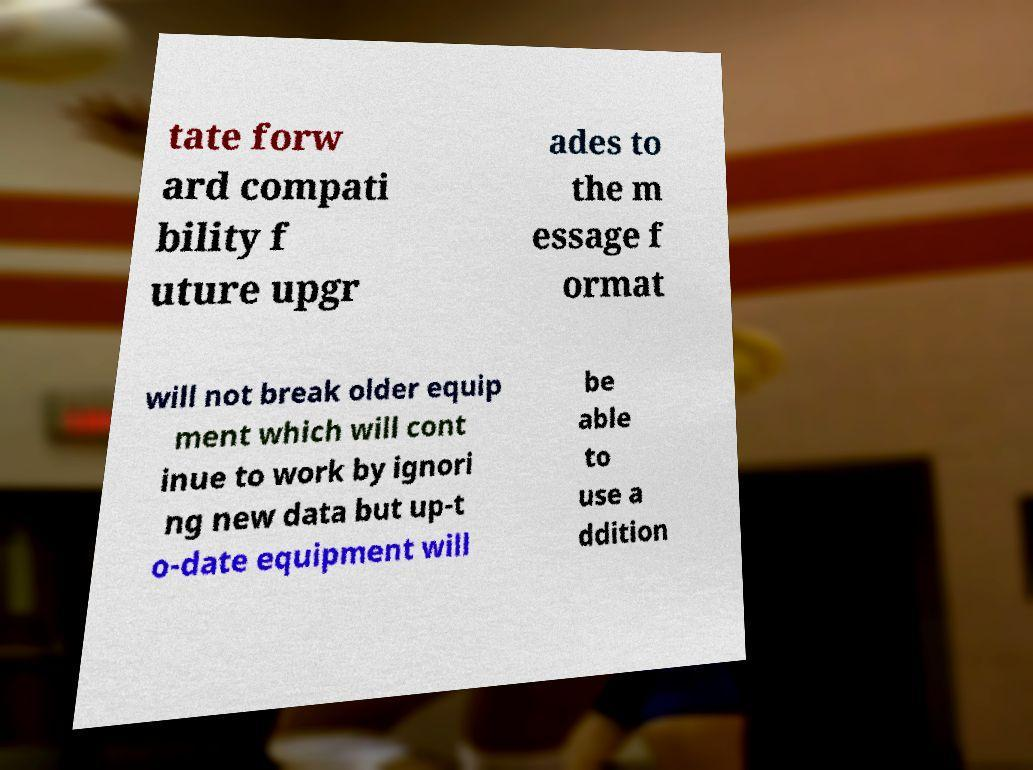Can you accurately transcribe the text from the provided image for me? tate forw ard compati bility f uture upgr ades to the m essage f ormat will not break older equip ment which will cont inue to work by ignori ng new data but up-t o-date equipment will be able to use a ddition 